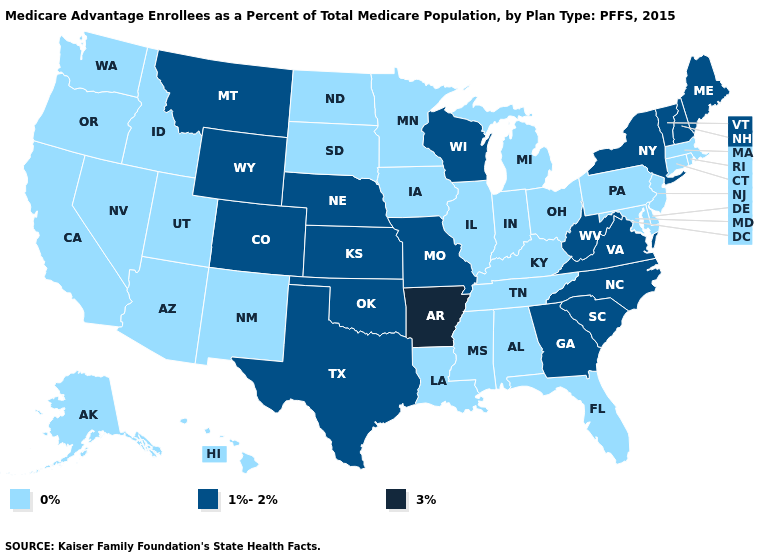Among the states that border Tennessee , does Arkansas have the highest value?
Quick response, please. Yes. Does South Carolina have the lowest value in the South?
Quick response, please. No. How many symbols are there in the legend?
Write a very short answer. 3. Among the states that border Kansas , which have the lowest value?
Give a very brief answer. Colorado, Missouri, Nebraska, Oklahoma. Which states have the lowest value in the USA?
Short answer required. Alaska, Alabama, Arizona, California, Connecticut, Delaware, Florida, Hawaii, Iowa, Idaho, Illinois, Indiana, Kentucky, Louisiana, Massachusetts, Maryland, Michigan, Minnesota, Mississippi, North Dakota, New Jersey, New Mexico, Nevada, Ohio, Oregon, Pennsylvania, Rhode Island, South Dakota, Tennessee, Utah, Washington. What is the highest value in the USA?
Be succinct. 3%. What is the highest value in the Northeast ?
Short answer required. 1%-2%. Name the states that have a value in the range 3%?
Quick response, please. Arkansas. Does Indiana have a lower value than Vermont?
Write a very short answer. Yes. Among the states that border Vermont , does Massachusetts have the highest value?
Quick response, please. No. Does the first symbol in the legend represent the smallest category?
Give a very brief answer. Yes. What is the highest value in the USA?
Concise answer only. 3%. Name the states that have a value in the range 0%?
Keep it brief. Alaska, Alabama, Arizona, California, Connecticut, Delaware, Florida, Hawaii, Iowa, Idaho, Illinois, Indiana, Kentucky, Louisiana, Massachusetts, Maryland, Michigan, Minnesota, Mississippi, North Dakota, New Jersey, New Mexico, Nevada, Ohio, Oregon, Pennsylvania, Rhode Island, South Dakota, Tennessee, Utah, Washington. What is the value of Missouri?
Short answer required. 1%-2%. What is the highest value in states that border California?
Be succinct. 0%. 